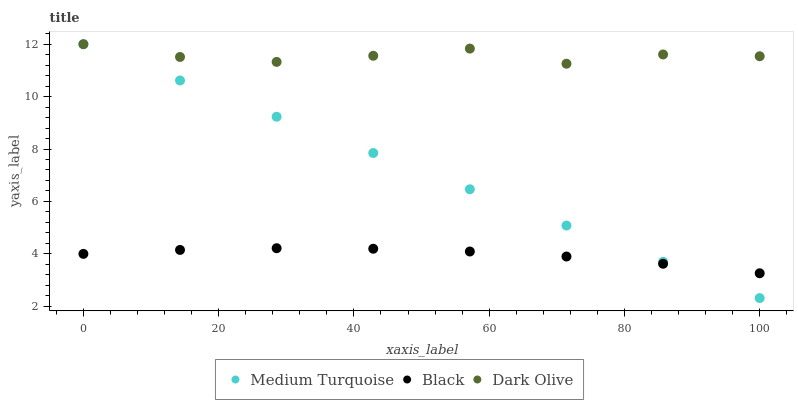Does Black have the minimum area under the curve?
Answer yes or no. Yes. Does Dark Olive have the maximum area under the curve?
Answer yes or no. Yes. Does Medium Turquoise have the minimum area under the curve?
Answer yes or no. No. Does Medium Turquoise have the maximum area under the curve?
Answer yes or no. No. Is Medium Turquoise the smoothest?
Answer yes or no. Yes. Is Dark Olive the roughest?
Answer yes or no. Yes. Is Black the smoothest?
Answer yes or no. No. Is Black the roughest?
Answer yes or no. No. Does Medium Turquoise have the lowest value?
Answer yes or no. Yes. Does Black have the lowest value?
Answer yes or no. No. Does Medium Turquoise have the highest value?
Answer yes or no. Yes. Does Black have the highest value?
Answer yes or no. No. Is Black less than Dark Olive?
Answer yes or no. Yes. Is Dark Olive greater than Black?
Answer yes or no. Yes. Does Dark Olive intersect Medium Turquoise?
Answer yes or no. Yes. Is Dark Olive less than Medium Turquoise?
Answer yes or no. No. Is Dark Olive greater than Medium Turquoise?
Answer yes or no. No. Does Black intersect Dark Olive?
Answer yes or no. No. 